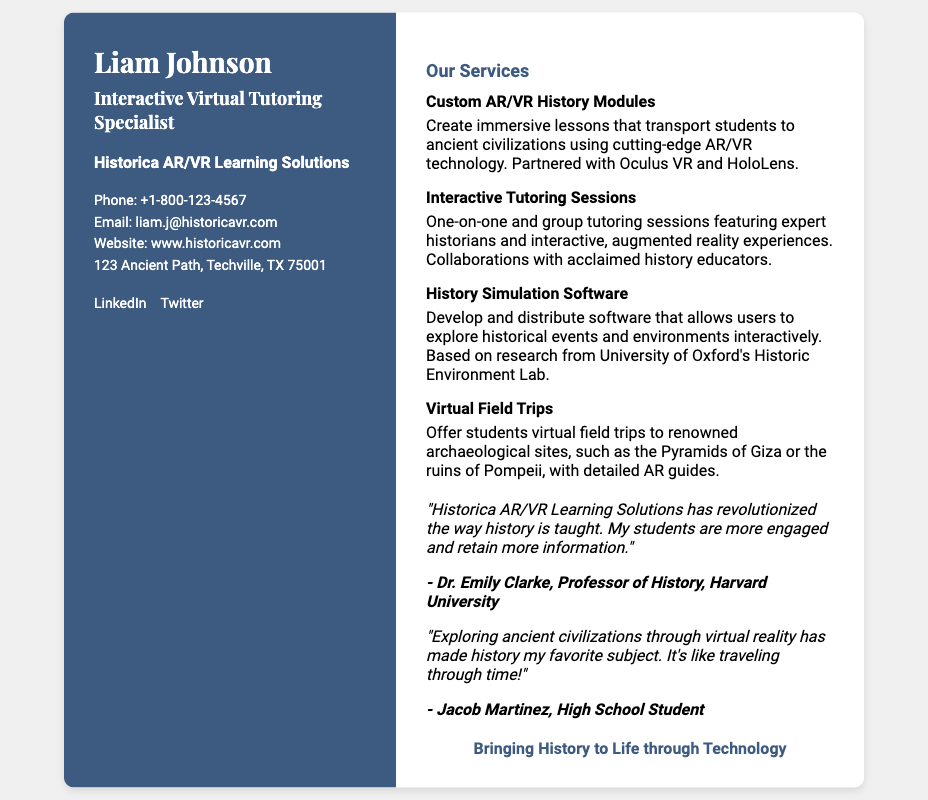What is the name of the specialist? The name of the specialist is prominently displayed at the top of the card as "Liam Johnson".
Answer: Liam Johnson What organization does Liam Johnson work for? The organization is mentioned below the name, stated as "Historica AR/VR Learning Solutions".
Answer: Historica AR/VR Learning Solutions What is the phone number provided? The phone number is listed under the contact information section as "+1-800-123-4567".
Answer: +1-800-123-4567 What service involves virtual field trips? The service that mentions virtual field trips is described as offering "Virtual Field Trips" to archaeological sites.
Answer: Virtual Field Trips Which company is partnered for AR/VR modules? The document states that the company is partnered with "Oculus VR and HoloLens" for creating AR/VR modules.
Answer: Oculus VR and HoloLens How are the tutoring sessions described? The tutoring sessions are referred to as "One-on-one and group tutoring sessions featuring expert historians".
Answer: One-on-one and group tutoring sessions featuring expert historians What is the tagline for the business? The tagline is presented at the bottom of the right column, stating their mission: "Bringing History to Life through Technology".
Answer: Bringing History to Life through Technology What is the location of the business? The address is specified in the contact information, which is "123 Ancient Path, Techville, TX 75001".
Answer: 123 Ancient Path, Techville, TX 75001 Who is Dr. Emily Clarke? Dr. Emily Clarke is a testimonial author described as a "Professor of History, Harvard University" in the testimonials section.
Answer: Professor of History, Harvard University 